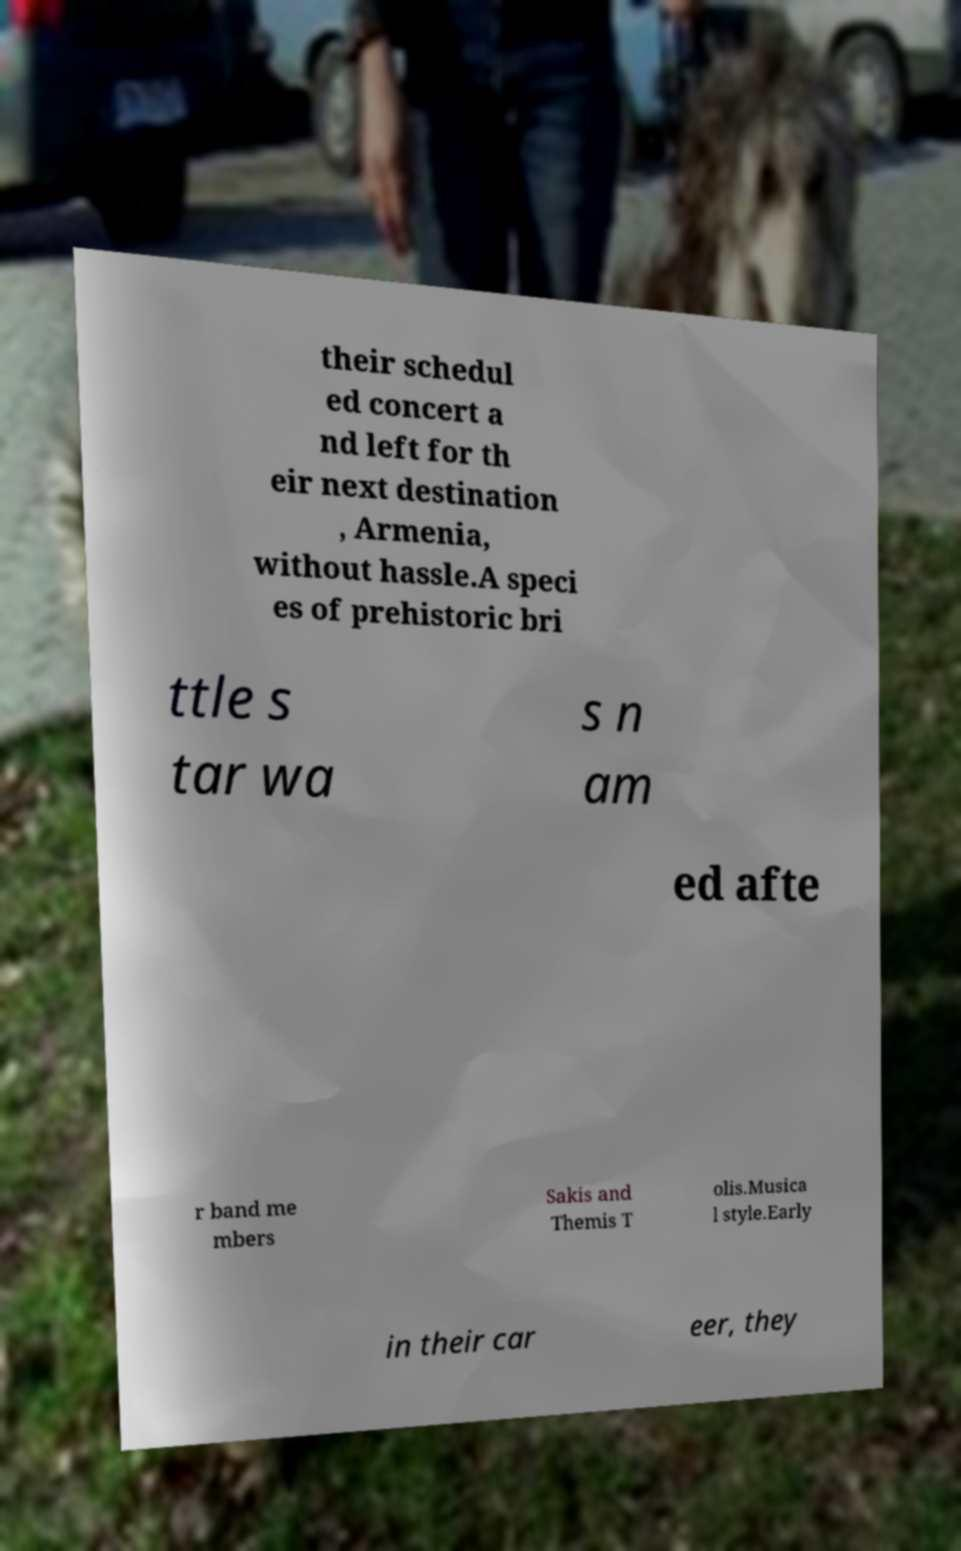Can you read and provide the text displayed in the image?This photo seems to have some interesting text. Can you extract and type it out for me? their schedul ed concert a nd left for th eir next destination , Armenia, without hassle.A speci es of prehistoric bri ttle s tar wa s n am ed afte r band me mbers Sakis and Themis T olis.Musica l style.Early in their car eer, they 